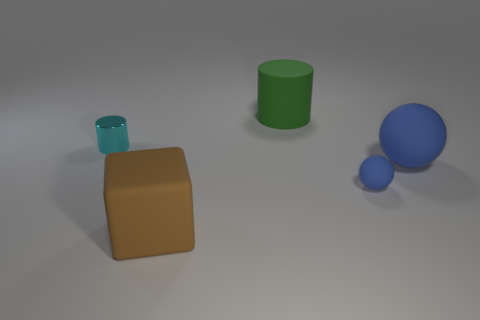Are there any metal cylinders right of the large blue rubber thing?
Your response must be concise. No. How many yellow things are either rubber spheres or matte things?
Your answer should be very brief. 0. Do the large brown block and the cylinder to the left of the large green cylinder have the same material?
Make the answer very short. No. There is another matte thing that is the same shape as the tiny cyan thing; what size is it?
Give a very brief answer. Large. What is the material of the tiny cyan thing?
Offer a very short reply. Metal. What material is the object behind the cylinder left of the thing that is behind the small cyan shiny cylinder?
Your answer should be very brief. Rubber. There is a cylinder in front of the green matte thing; does it have the same size as the cylinder to the right of the brown matte object?
Provide a succinct answer. No. What number of other objects are there of the same material as the large cube?
Provide a short and direct response. 3. How many matte objects are green objects or blue objects?
Offer a terse response. 3. Is the number of green cubes less than the number of large matte balls?
Your response must be concise. Yes. 